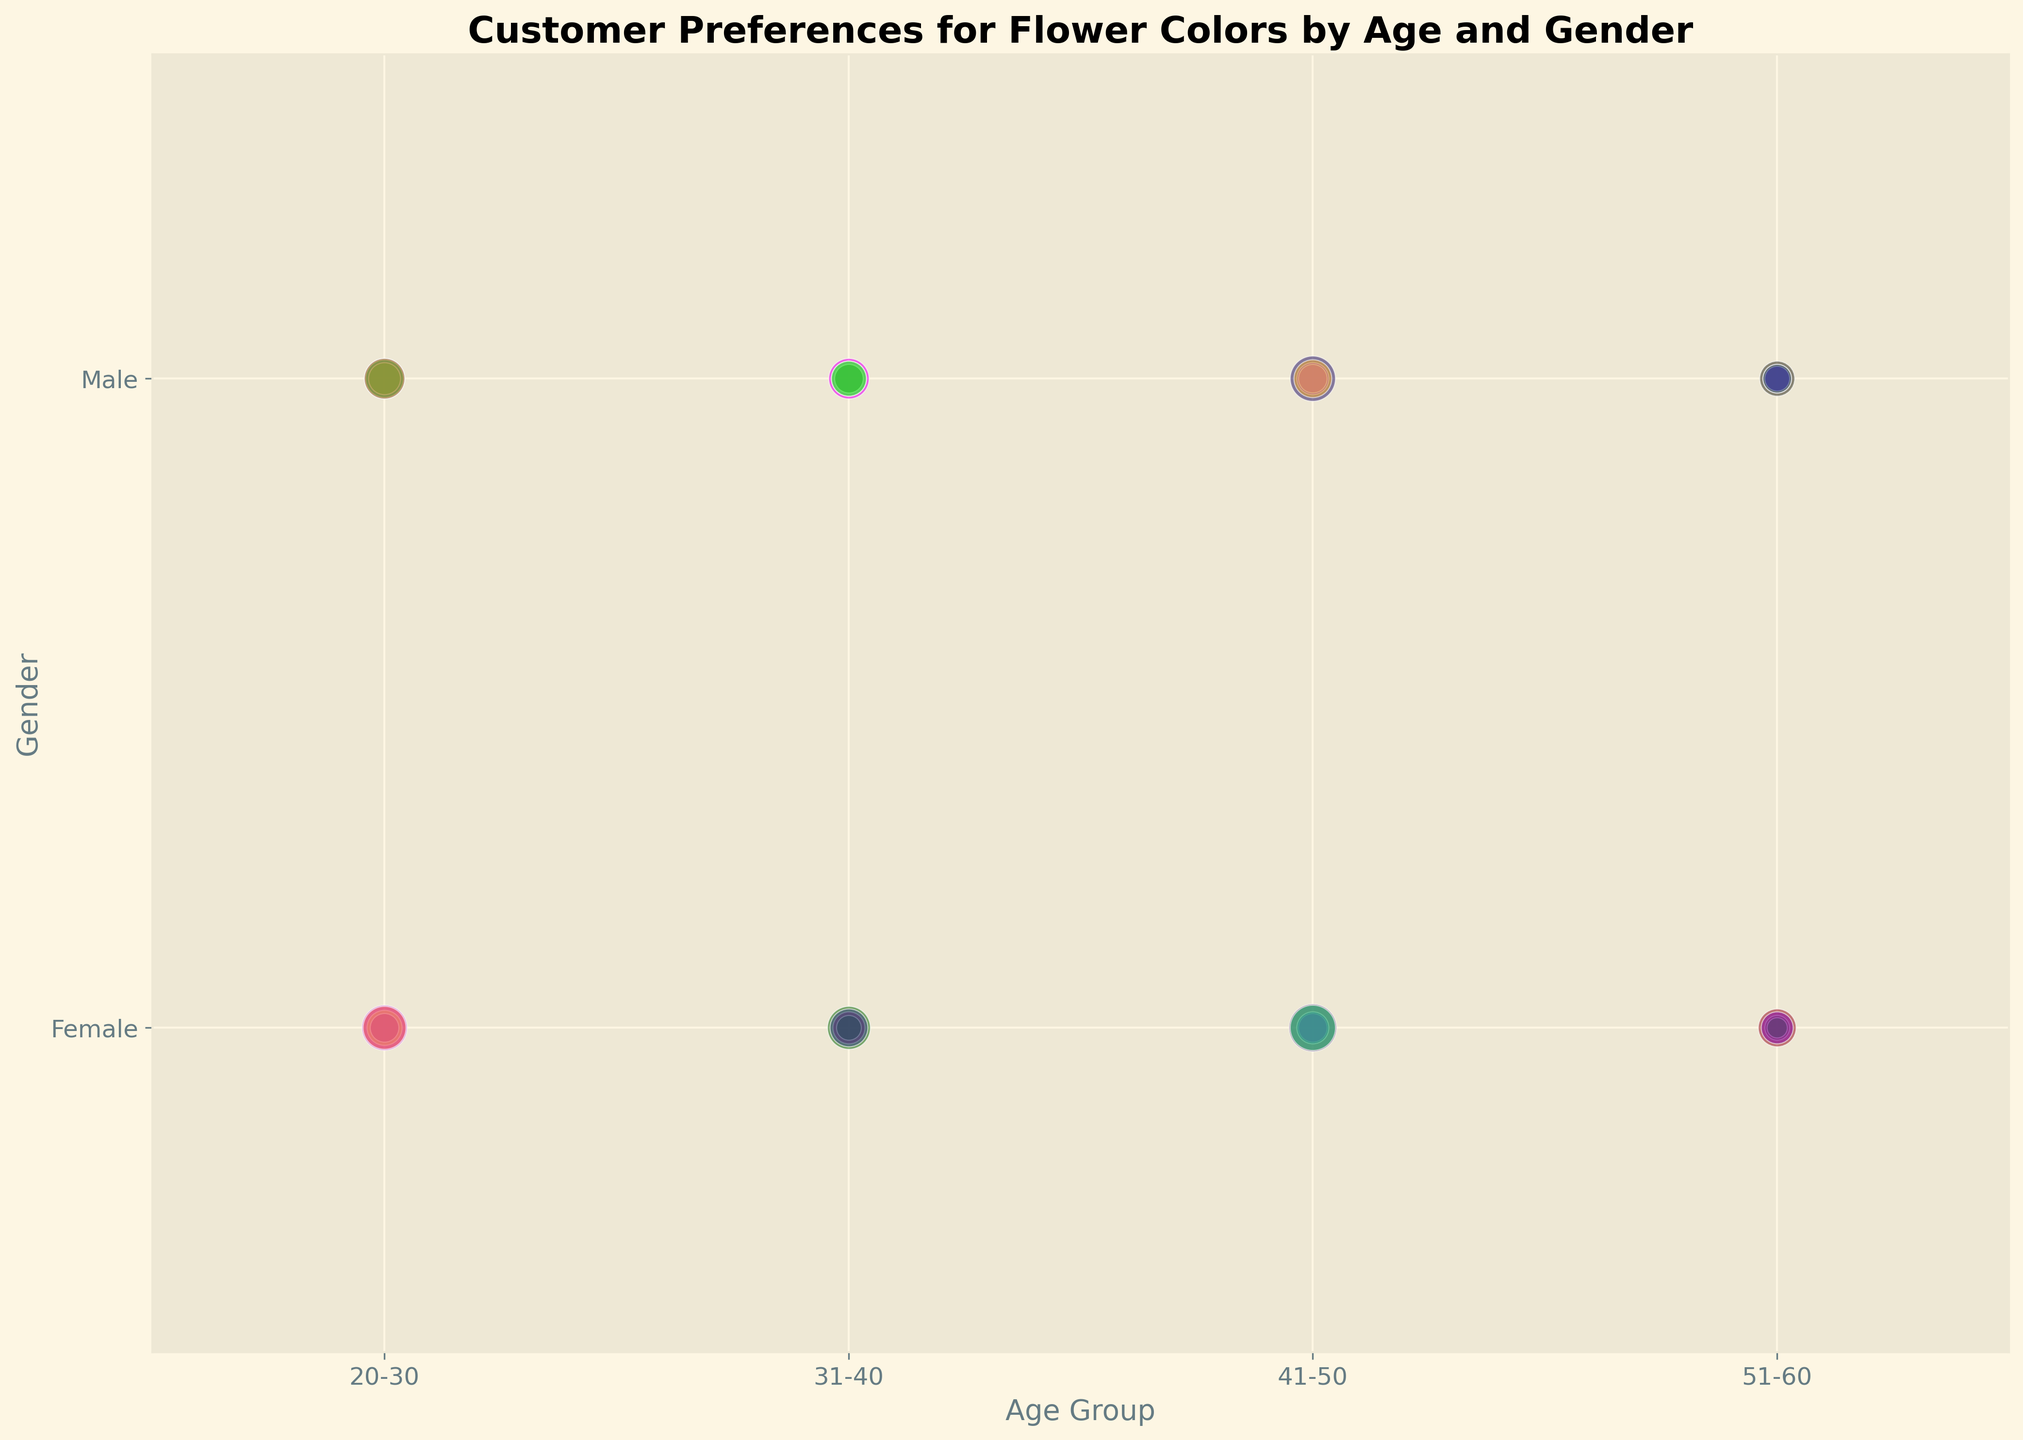What's the most preferred flower color among females aged 41-50? Based on the figure, the bubble size for 'Red' among females aged 41-50 is the largest, indicating the highest frequency.
Answer: Red Which age group has the highest preference for pink flowers among males? From the chart, males aged 41-50 have the largest bubble for pink flowers, indicating the highest preference.
Answer: 41-50 How does the preference for blue flowers compare between males aged 20-30 and 31-40? The bubble sizes indicate a frequency count. Males aged 20-30 have a larger bubble size for blue flowers than those aged 31-40. This suggests a higher preference among the younger age group.
Answer: 20-30 What is the total preference for red flowers among all age groups and both genders? Summing all the bubble sizes for red flowers across all age groups and both genders: 50 + 40 + 45 + 40 + 55 + 50 + 35 + 30 = 345.
Answer: 345 Which gender has a higher preference for yellow flowers in the age group 51-60? By comparing the bubble sizes in the given age group, males have a slightly larger bubble size for yellow flowers than females.
Answer: Male Which age group shows the least preference for yellow flowers among all the groups? The bubble size for yellow flowers is the smallest in the 51-60 age group for both genders compared to other age groups.
Answer: 51-60 Compare the preference for red flowers between males aged 20-30 and females aged 31-40. The bubble size for red flowers for these demographics shows males aged 20-30 have a bubble size of 40 and females aged 31-40 have a size of 45. Females aged 31-40 have a slightly higher preference.
Answer: Females aged 31-40 What's the average size of bubbles for blue flower preferences among females of all age groups? Adding bubble sizes for blue flowers among females and dividing by the number of groups: (30 + 25 + 20 + 15) / 4 = 22.5.
Answer: 22.5 Which color shows the greatest preference variability across different age groups? By observing the changes in bubble sizes across age groups, red shows substantial variability, suggesting it is the most variable in preference across age groups.
Answer: Red 